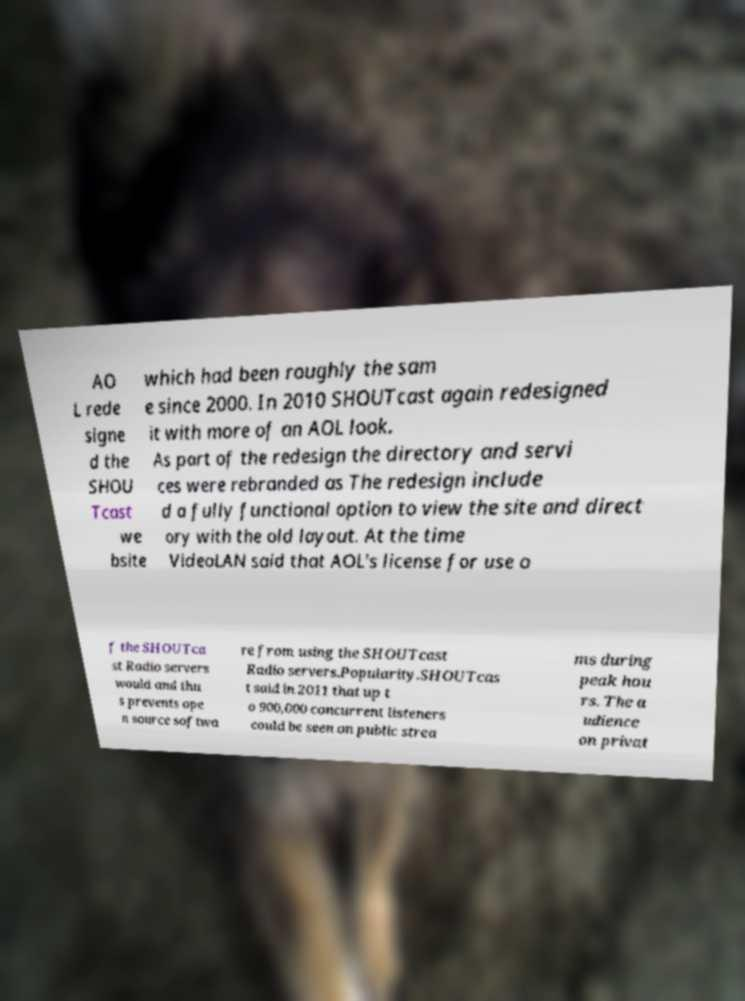There's text embedded in this image that I need extracted. Can you transcribe it verbatim? AO L rede signe d the SHOU Tcast we bsite which had been roughly the sam e since 2000. In 2010 SHOUTcast again redesigned it with more of an AOL look. As part of the redesign the directory and servi ces were rebranded as The redesign include d a fully functional option to view the site and direct ory with the old layout. At the time VideoLAN said that AOL's license for use o f the SHOUTca st Radio servers would and thu s prevents ope n source softwa re from using the SHOUTcast Radio servers.Popularity.SHOUTcas t said in 2011 that up t o 900,000 concurrent listeners could be seen on public strea ms during peak hou rs. The a udience on privat 